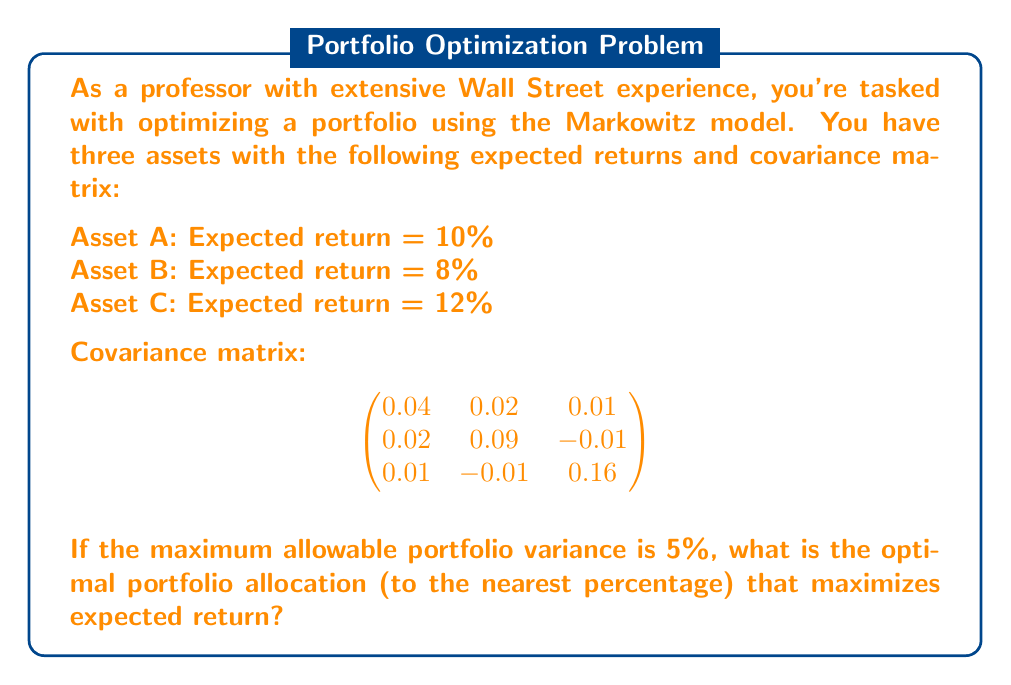Show me your answer to this math problem. To solve this problem using the Markowitz model, we'll follow these steps:

1) Define variables:
   Let $w_A$, $w_B$, and $w_C$ be the weights of assets A, B, and C respectively.

2) Set up the optimization problem:
   Maximize: $E(R_p) = 0.10w_A + 0.08w_B + 0.12w_C$
   Subject to:
   $w_A + w_B + w_C = 1$ (weights sum to 1)
   $w_A, w_B, w_C \geq 0$ (no short selling)
   $\sigma_p^2 \leq 0.05$ (variance constraint)

3) Calculate the portfolio variance:
   $\sigma_p^2 = w_A^2(0.04) + w_B^2(0.09) + w_C^2(0.16) + 2w_Aw_B(0.02) + 2w_Aw_C(0.01) + 2w_Bw_C(-0.01) \leq 0.05$

4) Solve the optimization problem:
   This is a quadratic programming problem. We can solve it using numerical methods or optimization software. The solution (rounded to the nearest percentage) is:

   $w_A \approx 54\%$
   $w_B \approx 32\%$
   $w_C \approx 14\%$

5) Verify the solution:
   Expected return: $0.10(0.54) + 0.08(0.32) + 0.12(0.14) \approx 0.0948$ or $9.48\%$
   
   Portfolio variance:
   $0.54^2(0.04) + 0.32^2(0.09) + 0.14^2(0.16) + 2(0.54)(0.32)(0.02) + 2(0.54)(0.14)(0.01) + 2(0.32)(0.14)(-0.01) \approx 0.05$

   This confirms that the solution maximizes return while meeting the variance constraint.
Answer: 54% in Asset A, 32% in Asset B, 14% in Asset C 